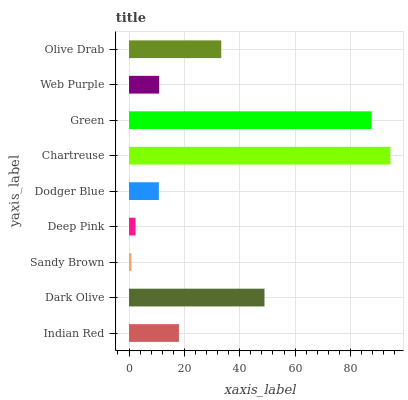Is Sandy Brown the minimum?
Answer yes or no. Yes. Is Chartreuse the maximum?
Answer yes or no. Yes. Is Dark Olive the minimum?
Answer yes or no. No. Is Dark Olive the maximum?
Answer yes or no. No. Is Dark Olive greater than Indian Red?
Answer yes or no. Yes. Is Indian Red less than Dark Olive?
Answer yes or no. Yes. Is Indian Red greater than Dark Olive?
Answer yes or no. No. Is Dark Olive less than Indian Red?
Answer yes or no. No. Is Indian Red the high median?
Answer yes or no. Yes. Is Indian Red the low median?
Answer yes or no. Yes. Is Dodger Blue the high median?
Answer yes or no. No. Is Olive Drab the low median?
Answer yes or no. No. 